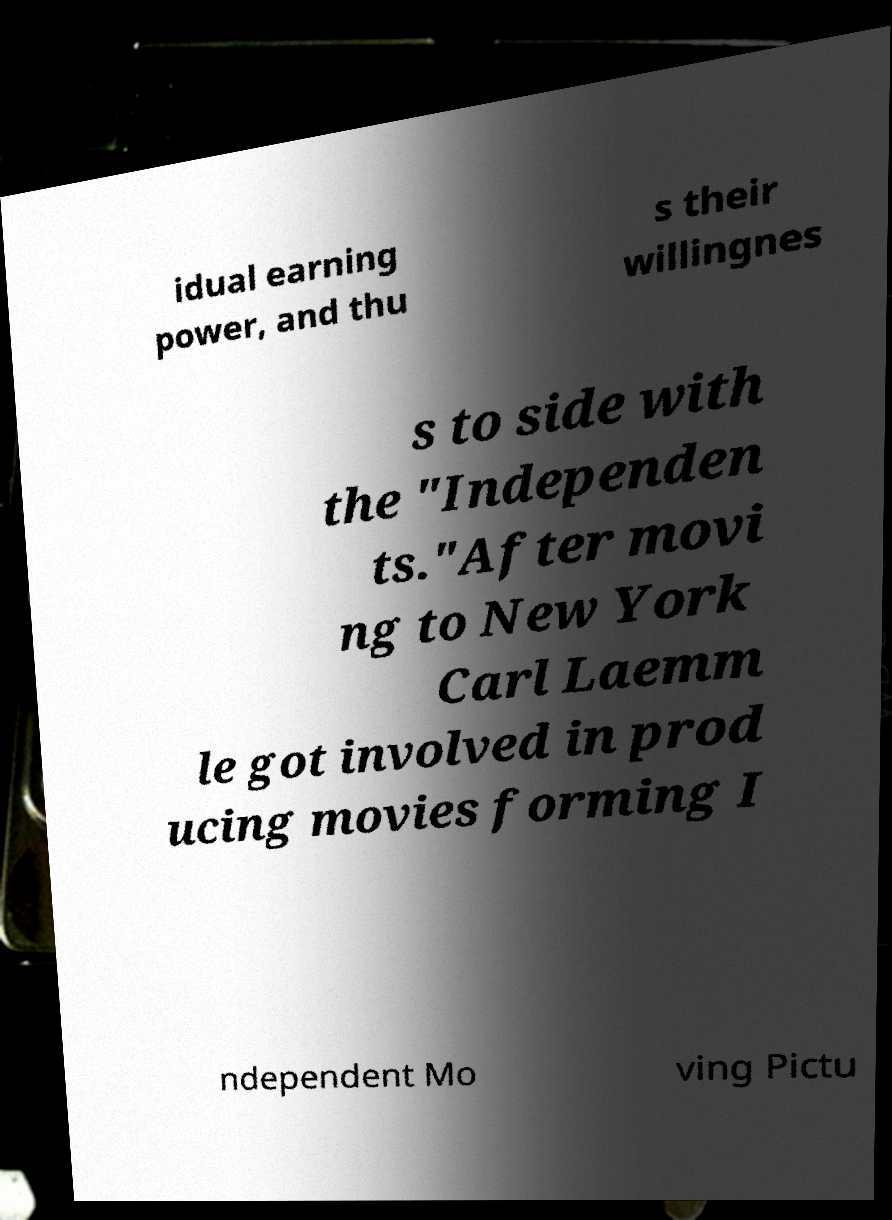What messages or text are displayed in this image? I need them in a readable, typed format. idual earning power, and thu s their willingnes s to side with the "Independen ts."After movi ng to New York Carl Laemm le got involved in prod ucing movies forming I ndependent Mo ving Pictu 